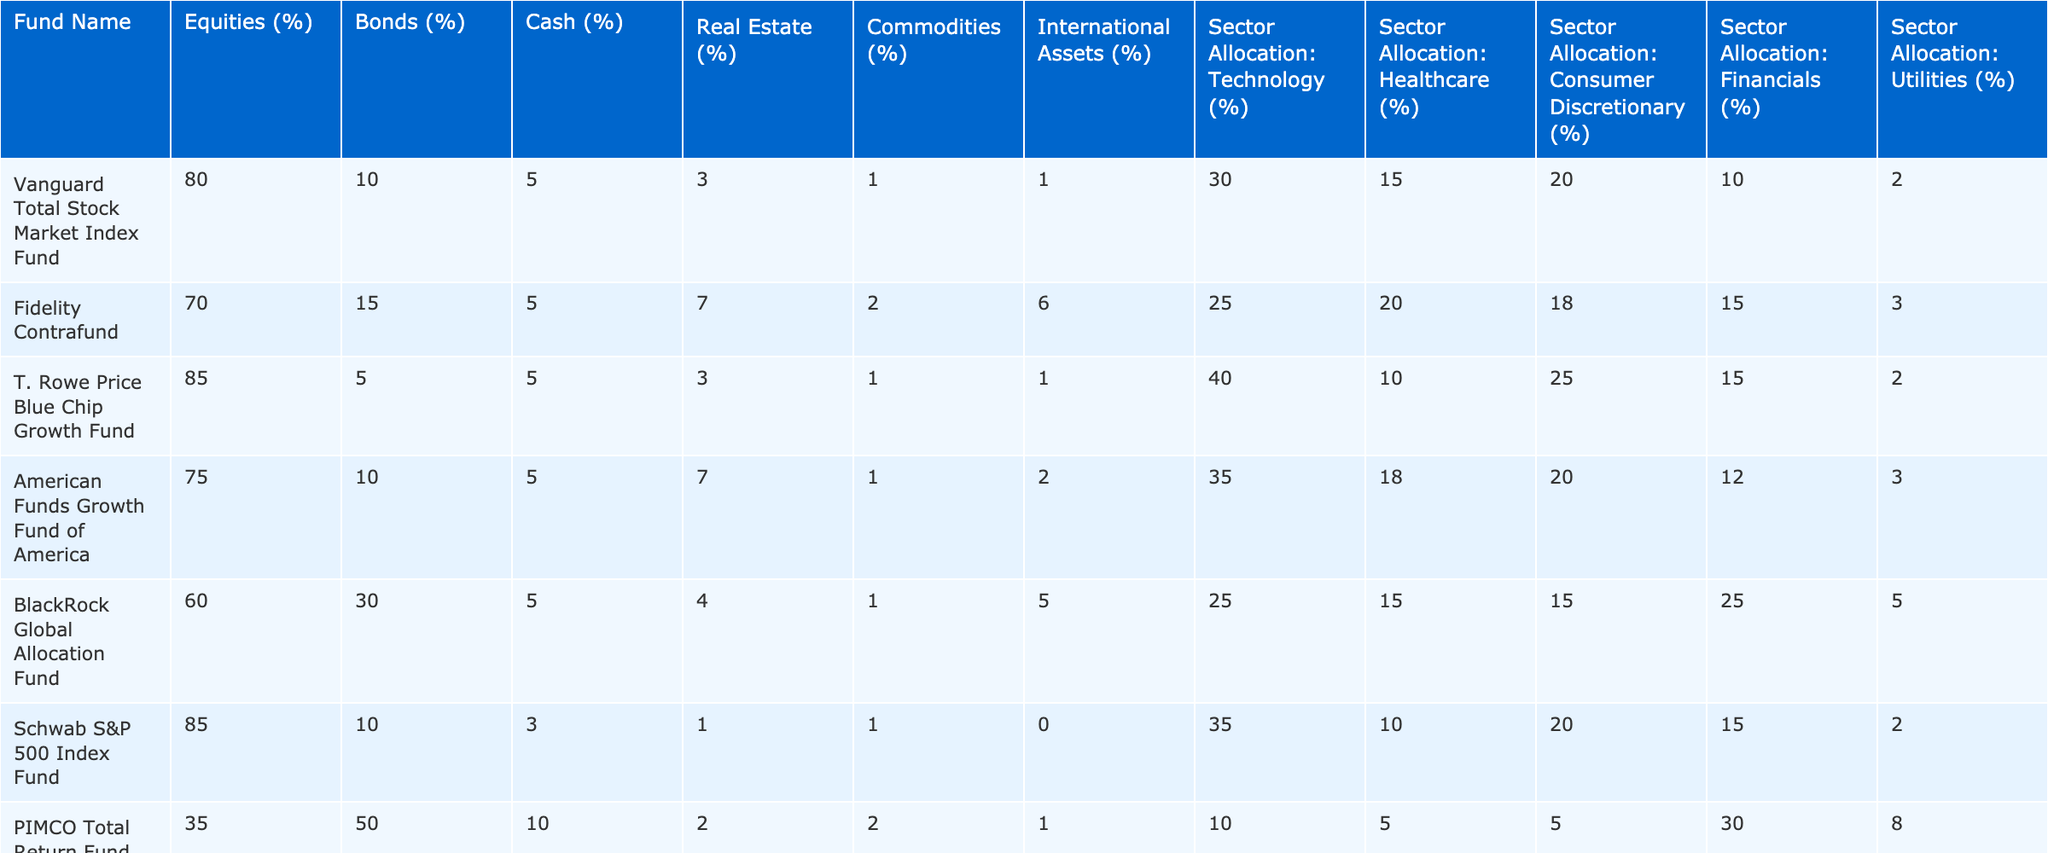What percentage of Vanguard Total Stock Market Index Fund is allocated to Bonds? The table shows that the Vanguard Total Stock Market Index Fund has 10% allocated to Bonds.
Answer: 10% Which fund has the highest allocation in International Assets? The Dodge & Cox Stock Fund and the PIMCO Total Return Fund each have 1% in International Assets, but PIMCO has a unique lower asset distribution. The other values are higher, but the total assets don't exceed other funds' allocation.
Answer: 1% What is the average percentage allocation to Cash across all funds? The Cash allocations are 5, 5, 5, 5, 5, 3, 10, 3, 5, and 5; summing these values gives 50, and there are 10 funds, thus the average is 50/10 = 5%.
Answer: 5% Does the Franklin Growth Fund have more than 20% in Equities? The table indicates that the Franklin Growth Fund has 75% in Equities, which is more than 20%.
Answer: Yes Which fund has the greatest percentage allocated to Real Estate? The American Funds Growth Fund and the Fidelity Contrafund both allocate 7% to Real Estate, making them the top funds for this category.
Answer: 7% If we combine the sector allocations of Technology and Consumer Discretionary for T. Rowe Price Blue Chip Growth Fund, what would that total be? The T. Rowe Price Blue Chip Growth Fund allocates 40% to Technology and 25% to Consumer Discretionary. Adding these gives 40 + 25 = 65%.
Answer: 65% What percentage of the PIMCO Total Return Fund is allocated to Bonds? According to the data, the PIMCO Total Return Fund has 50% allocated to Bonds.
Answer: 50% Which fund has a greater allocation to Utilities, Dodge & Cox Stock Fund or Fidelity Contrafund? The Dodge & Cox Stock Fund has 4% in Utilities while the Fidelity Contrafund has 3%, meaning Dodge & Cox has a greater allocation.
Answer: Dodge & Cox Stock Fund What is the total percentage allocation to Commodities across all four funds with the lowest percentage in Equities? The four funds with the lowest Equities are: PIMCO Total Return Fund (35%), BlackRock Global Allocation Fund (60%), Fidelity Contrafund (70%), and Dodge & Cox Stock Fund (70%). Commodities allocations for these are: 2, 1, 2, 1 respectively. Adding these gives 2 + 1 + 2 + 1 = 6%.
Answer: 6% Did any mutual fund allocate more than 30% to the Healthcare sector? The table indicates that no fund has allocated more than 30% to the Healthcare sector, as the highest is only 25% from the BlackRock Global Allocation Fund.
Answer: No 